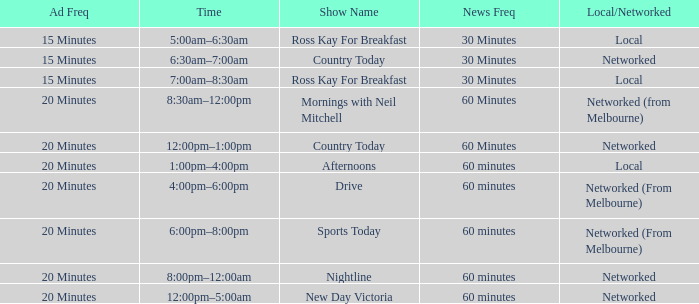What Time has a Show Name of mornings with neil mitchell? 8:30am–12:00pm. 